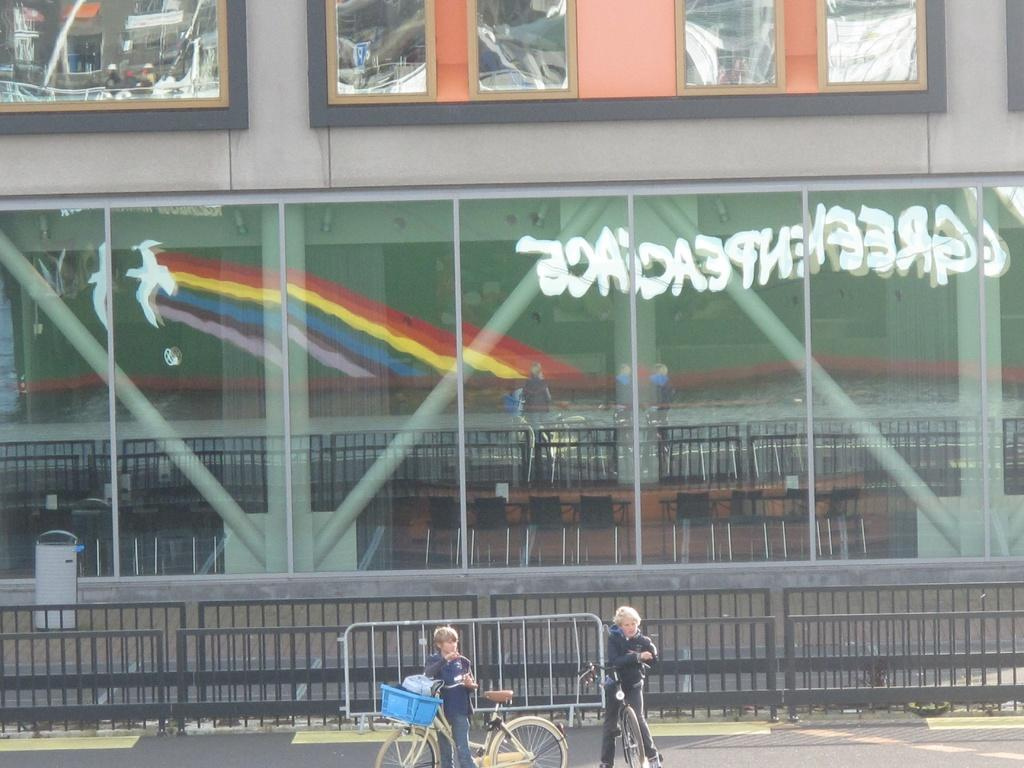<image>
Present a compact description of the photo's key features. a store front that has white writing on it and a rainbow 